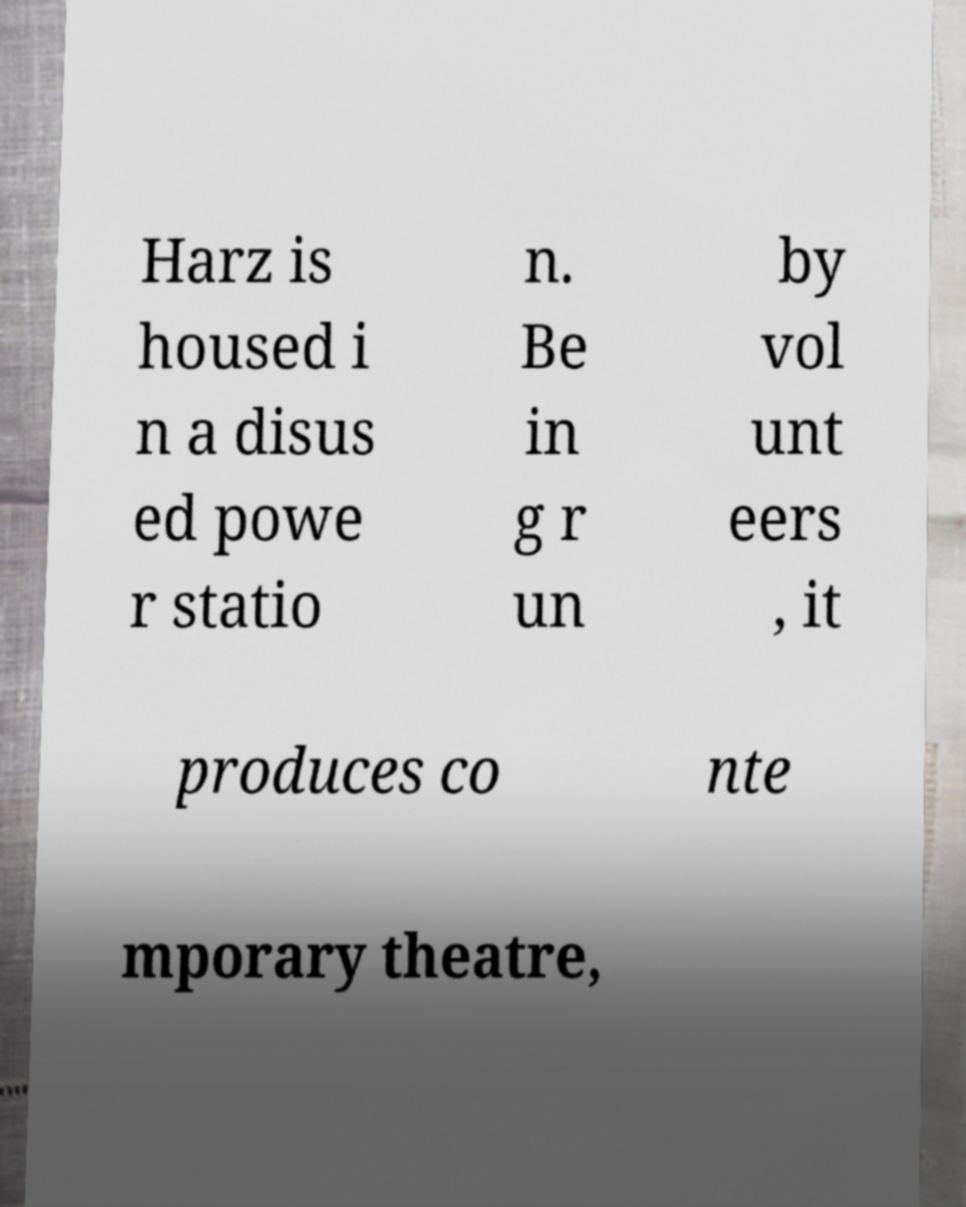Please identify and transcribe the text found in this image. Harz is housed i n a disus ed powe r statio n. Be in g r un by vol unt eers , it produces co nte mporary theatre, 